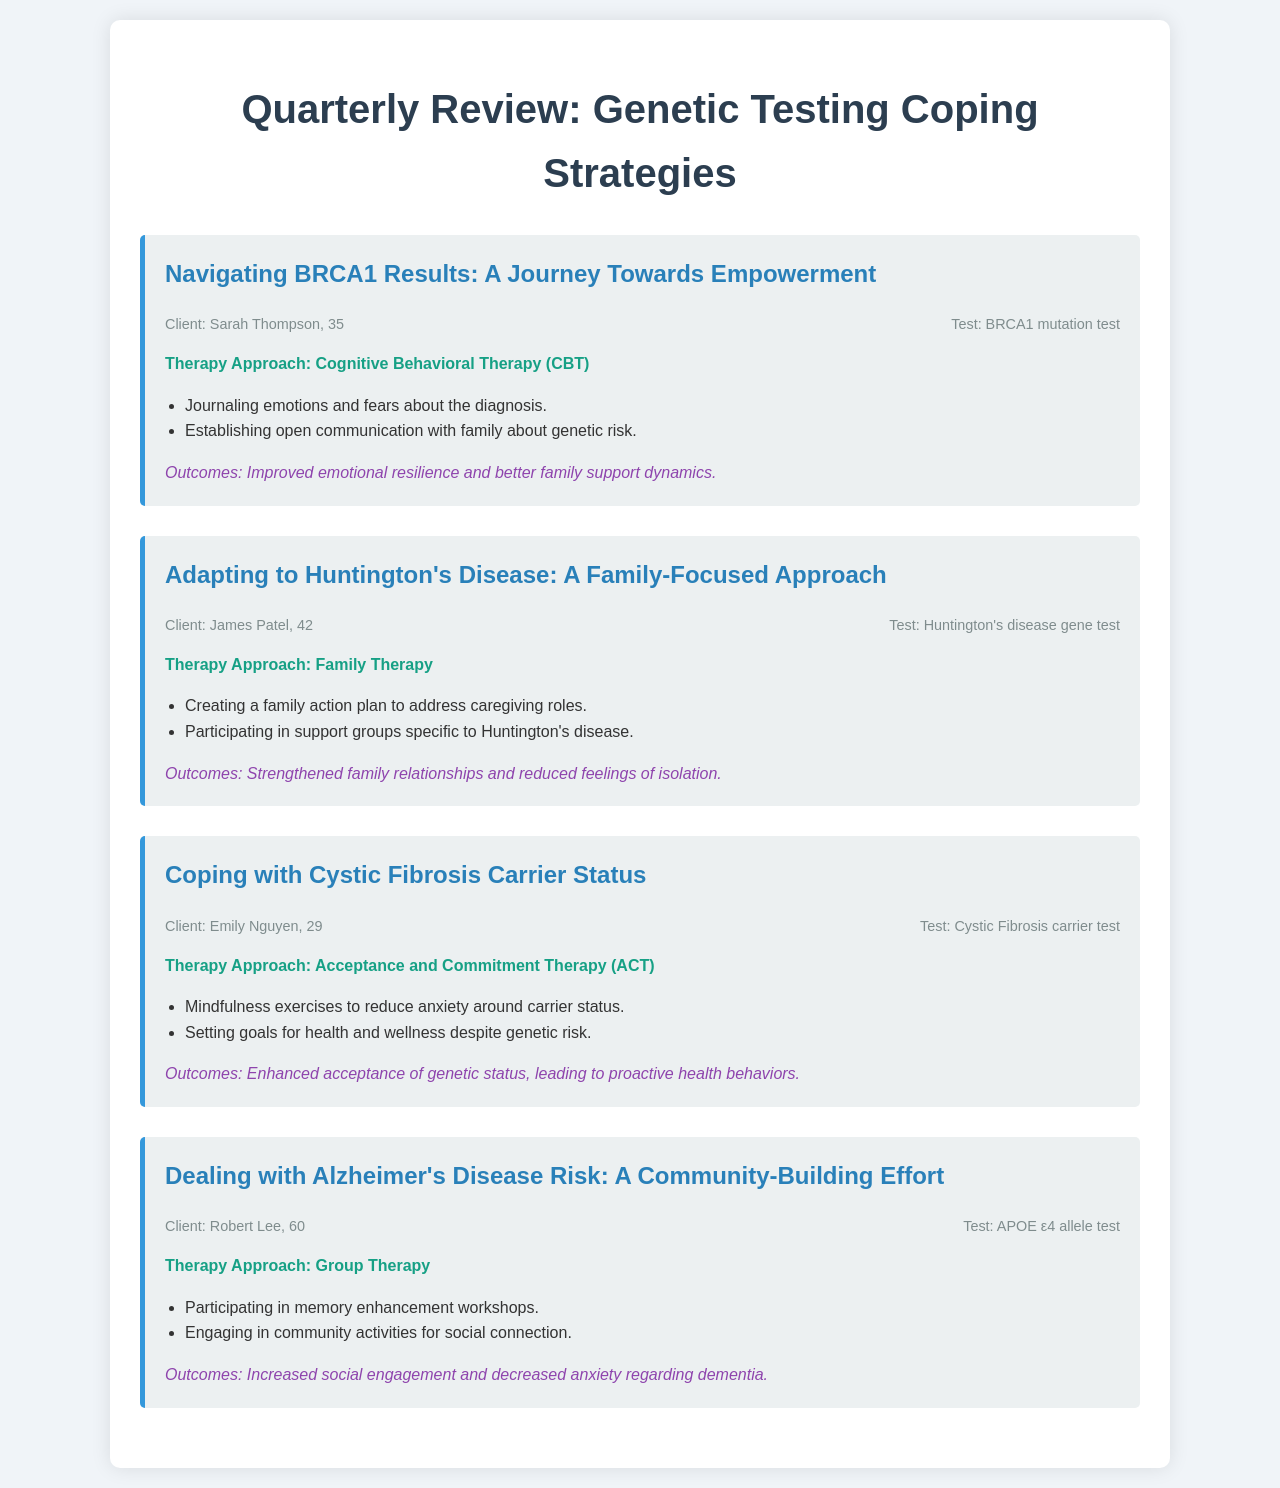what is the title of the document? The title is prominently displayed at the top of the document, which summarizes the focus of the content.
Answer: Quarterly Review: Genetic Testing Coping Strategies who is the first client mentioned in the case studies? The first client is noted in the first case study, where their name is introduced along with details about their genetic test.
Answer: Sarah Thompson what therapy approach did James Patel utilize? The document lists the therapy approach associated with James Patel's case, which is highlighted in his section.
Answer: Family Therapy how many case studies are included in the document? The number of case studies is revealed by counting the individual sections dedicated to each case.
Answer: Four what was the outcome for Sarah Thompson after her therapy? The outcome for Sarah Thompson is provided at the end of her case study, indicating the effects of her coping strategies.
Answer: Improved emotional resilience and better family support dynamics why did Emily Nguyen use Acceptance and Commitment Therapy? The reasoning behind Emily Nguyen's therapy approach is explained in the context of her specific genetic testing situation.
Answer: To reduce anxiety around carrier status what is the focus of Robert Lee’s therapy approach? The focus refers to the type of activities or engagements that Robert Lee participated in as part of his therapy.
Answer: Group Therapy which genetic test did Emily Nguyen undergo? The specific genetic test related to Emily Nguyen is clearly indicated in her case study section.
Answer: Cystic Fibrosis carrier test 